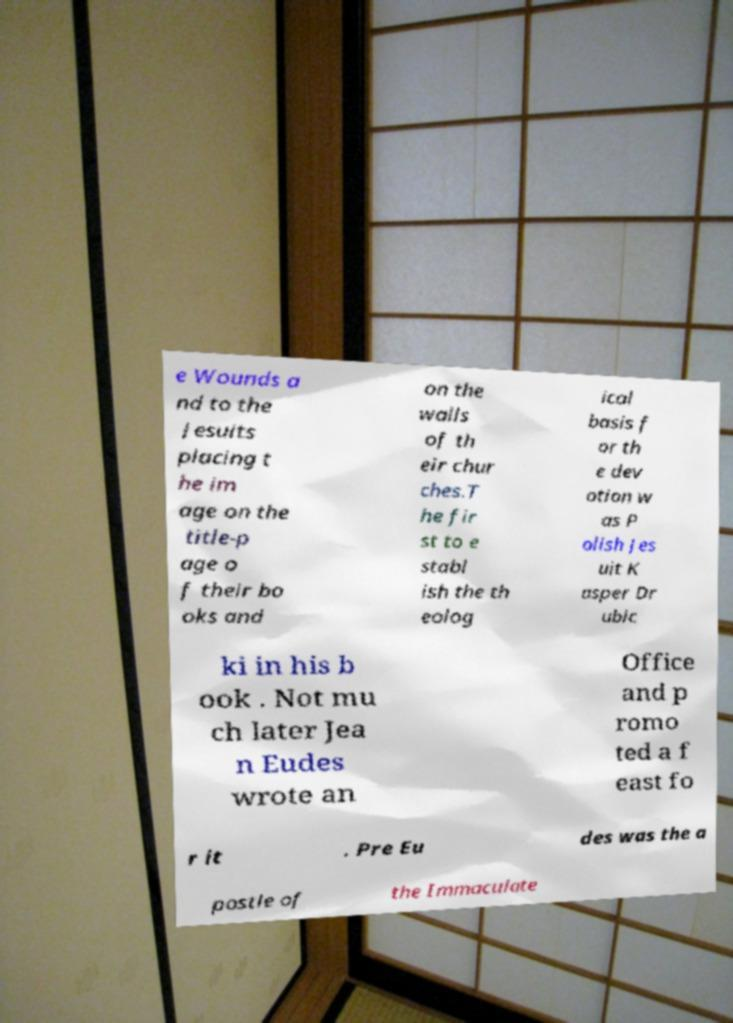Could you assist in decoding the text presented in this image and type it out clearly? e Wounds a nd to the Jesuits placing t he im age on the title-p age o f their bo oks and on the walls of th eir chur ches.T he fir st to e stabl ish the th eolog ical basis f or th e dev otion w as P olish Jes uit K asper Dr ubic ki in his b ook . Not mu ch later Jea n Eudes wrote an Office and p romo ted a f east fo r it . Pre Eu des was the a postle of the Immaculate 